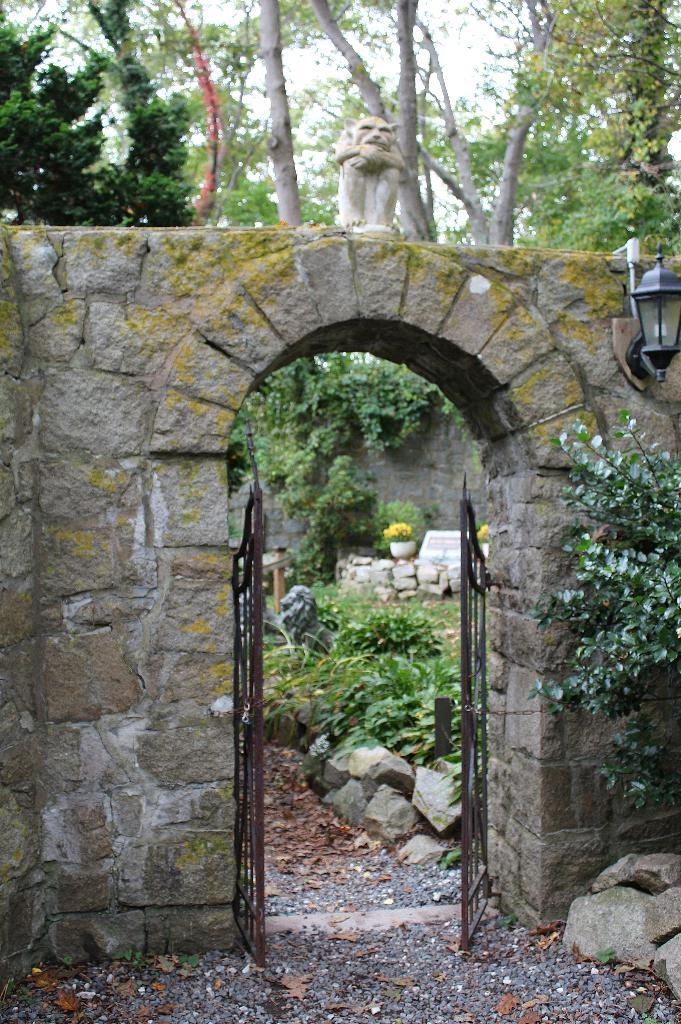What type of vegetation can be seen in the image? There are plants and trees in the image. What structure is located in the middle of the image? There is a gate in the middle of the image. What can be used to provide illumination in the image? There is a light in the image. What is present on the right side of the image? There is a branch on the right side of the image. Can you see a flock of birds flying over the trees in the image? There is no mention of birds or a flock in the image; it only features plants, trees, a gate, a light, and a branch. 